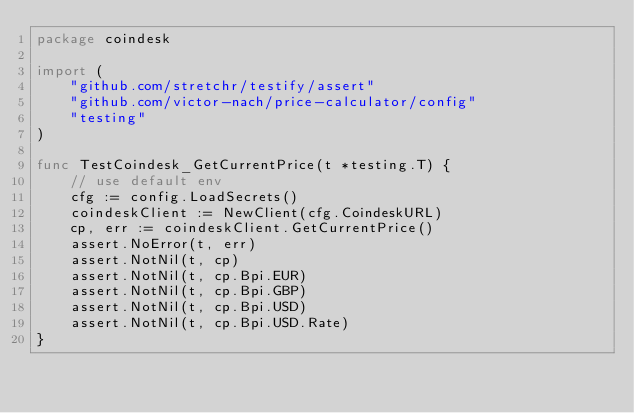<code> <loc_0><loc_0><loc_500><loc_500><_Go_>package coindesk

import (
	"github.com/stretchr/testify/assert"
	"github.com/victor-nach/price-calculator/config"
	"testing"
)

func TestCoindesk_GetCurrentPrice(t *testing.T) {
	// use default env
	cfg := config.LoadSecrets()
	coindeskClient := NewClient(cfg.CoindeskURL)
	cp, err := coindeskClient.GetCurrentPrice()
	assert.NoError(t, err)
	assert.NotNil(t, cp)
	assert.NotNil(t, cp.Bpi.EUR)
	assert.NotNil(t, cp.Bpi.GBP)
	assert.NotNil(t, cp.Bpi.USD)
	assert.NotNil(t, cp.Bpi.USD.Rate)
}
</code> 